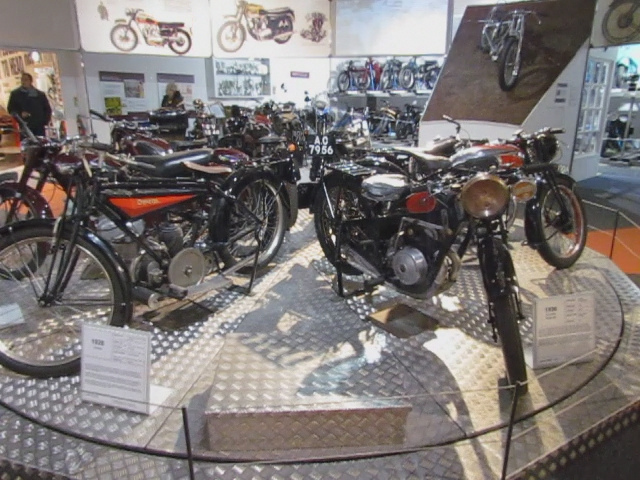Can you tell me more about the history of these motorcycles? Certainly! The motorcycles showcased here span various decades, reflecting the evolution of design and technology in motorbike manufacturing. Each model comes with its own unique story, often tied to the era it was produced in and the cultural backdrop of that time. 